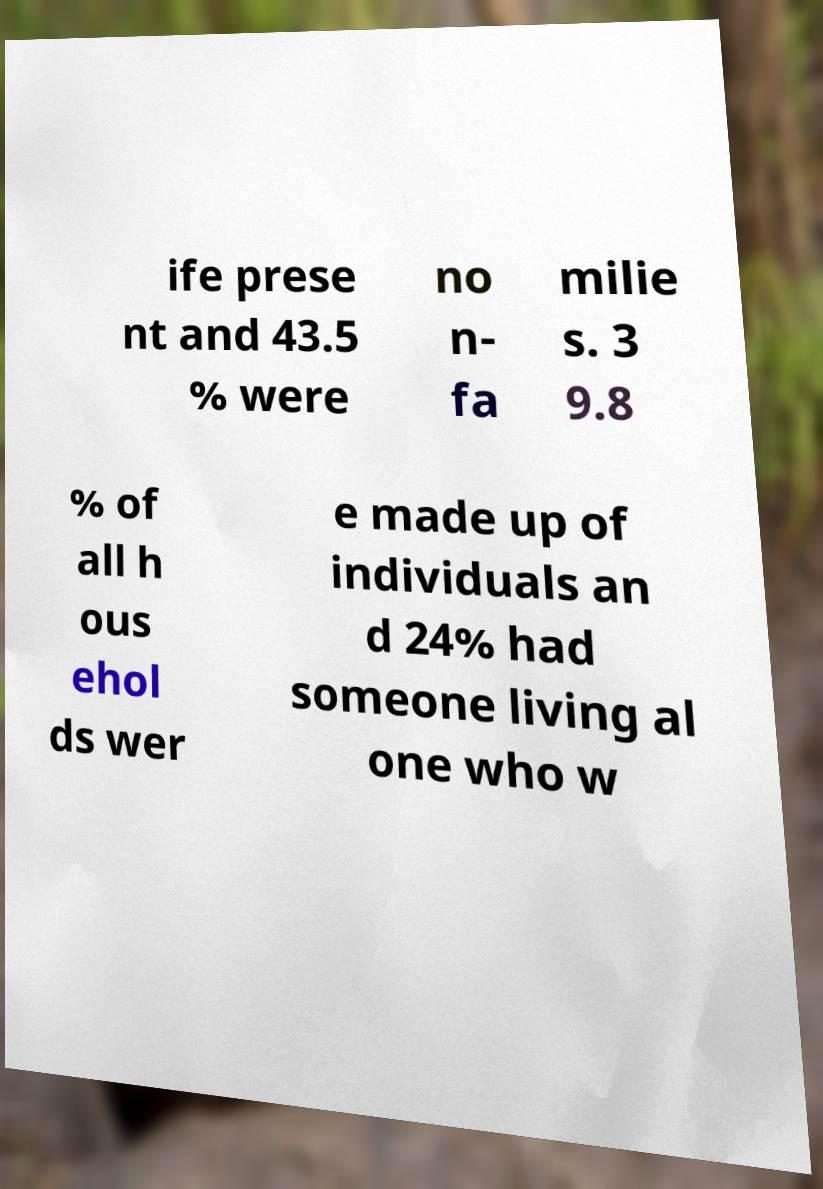Can you read and provide the text displayed in the image?This photo seems to have some interesting text. Can you extract and type it out for me? ife prese nt and 43.5 % were no n- fa milie s. 3 9.8 % of all h ous ehol ds wer e made up of individuals an d 24% had someone living al one who w 